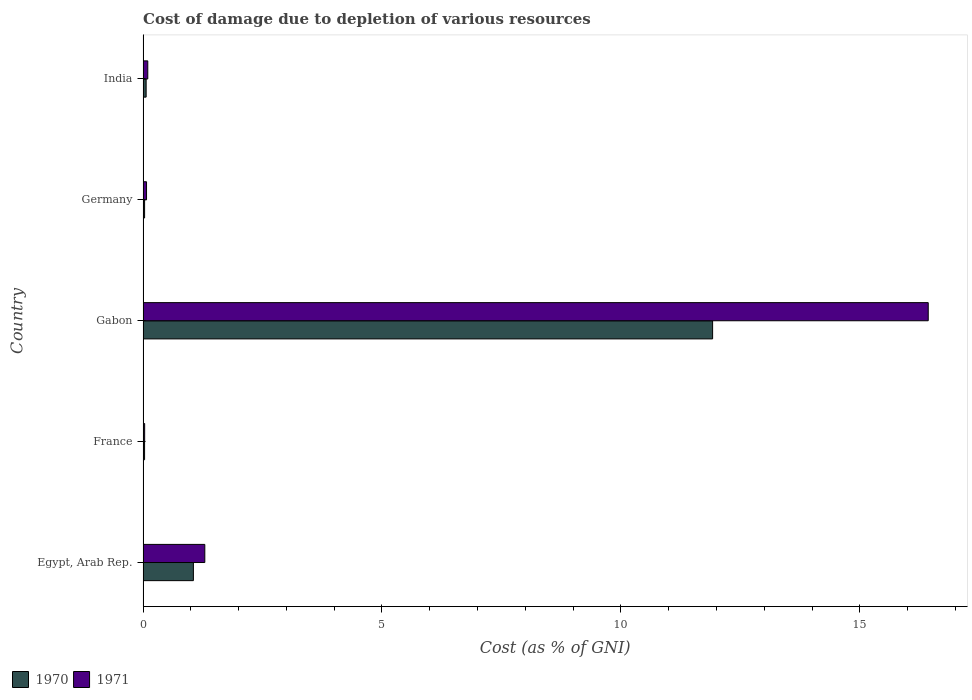How many groups of bars are there?
Your response must be concise. 5. Are the number of bars per tick equal to the number of legend labels?
Give a very brief answer. Yes. How many bars are there on the 3rd tick from the top?
Offer a very short reply. 2. How many bars are there on the 4th tick from the bottom?
Your answer should be very brief. 2. What is the cost of damage caused due to the depletion of various resources in 1970 in India?
Provide a succinct answer. 0.06. Across all countries, what is the maximum cost of damage caused due to the depletion of various resources in 1970?
Provide a succinct answer. 11.92. Across all countries, what is the minimum cost of damage caused due to the depletion of various resources in 1971?
Make the answer very short. 0.03. In which country was the cost of damage caused due to the depletion of various resources in 1971 maximum?
Provide a short and direct response. Gabon. What is the total cost of damage caused due to the depletion of various resources in 1971 in the graph?
Your answer should be compact. 17.93. What is the difference between the cost of damage caused due to the depletion of various resources in 1970 in Gabon and that in India?
Your answer should be compact. 11.85. What is the difference between the cost of damage caused due to the depletion of various resources in 1970 in Egypt, Arab Rep. and the cost of damage caused due to the depletion of various resources in 1971 in France?
Your answer should be very brief. 1.02. What is the average cost of damage caused due to the depletion of various resources in 1970 per country?
Offer a terse response. 2.62. What is the difference between the cost of damage caused due to the depletion of various resources in 1971 and cost of damage caused due to the depletion of various resources in 1970 in Germany?
Your answer should be very brief. 0.04. In how many countries, is the cost of damage caused due to the depletion of various resources in 1970 greater than 3 %?
Your response must be concise. 1. What is the ratio of the cost of damage caused due to the depletion of various resources in 1970 in Egypt, Arab Rep. to that in Gabon?
Make the answer very short. 0.09. Is the cost of damage caused due to the depletion of various resources in 1971 in Egypt, Arab Rep. less than that in India?
Give a very brief answer. No. Is the difference between the cost of damage caused due to the depletion of various resources in 1971 in Egypt, Arab Rep. and Gabon greater than the difference between the cost of damage caused due to the depletion of various resources in 1970 in Egypt, Arab Rep. and Gabon?
Your answer should be compact. No. What is the difference between the highest and the second highest cost of damage caused due to the depletion of various resources in 1970?
Ensure brevity in your answer.  10.87. What is the difference between the highest and the lowest cost of damage caused due to the depletion of various resources in 1970?
Provide a succinct answer. 11.89. In how many countries, is the cost of damage caused due to the depletion of various resources in 1971 greater than the average cost of damage caused due to the depletion of various resources in 1971 taken over all countries?
Give a very brief answer. 1. What does the 1st bar from the top in Germany represents?
Give a very brief answer. 1971. How many bars are there?
Keep it short and to the point. 10. Are all the bars in the graph horizontal?
Offer a very short reply. Yes. How many countries are there in the graph?
Give a very brief answer. 5. What is the difference between two consecutive major ticks on the X-axis?
Your response must be concise. 5. Does the graph contain grids?
Offer a terse response. No. Where does the legend appear in the graph?
Make the answer very short. Bottom left. How many legend labels are there?
Your answer should be compact. 2. How are the legend labels stacked?
Your answer should be very brief. Horizontal. What is the title of the graph?
Provide a short and direct response. Cost of damage due to depletion of various resources. What is the label or title of the X-axis?
Provide a short and direct response. Cost (as % of GNI). What is the Cost (as % of GNI) of 1970 in Egypt, Arab Rep.?
Your response must be concise. 1.05. What is the Cost (as % of GNI) in 1971 in Egypt, Arab Rep.?
Your response must be concise. 1.29. What is the Cost (as % of GNI) of 1970 in France?
Ensure brevity in your answer.  0.03. What is the Cost (as % of GNI) in 1971 in France?
Make the answer very short. 0.03. What is the Cost (as % of GNI) of 1970 in Gabon?
Provide a short and direct response. 11.92. What is the Cost (as % of GNI) in 1971 in Gabon?
Your answer should be very brief. 16.43. What is the Cost (as % of GNI) of 1970 in Germany?
Offer a very short reply. 0.03. What is the Cost (as % of GNI) of 1971 in Germany?
Provide a succinct answer. 0.07. What is the Cost (as % of GNI) of 1970 in India?
Keep it short and to the point. 0.06. What is the Cost (as % of GNI) in 1971 in India?
Keep it short and to the point. 0.1. Across all countries, what is the maximum Cost (as % of GNI) of 1970?
Offer a terse response. 11.92. Across all countries, what is the maximum Cost (as % of GNI) in 1971?
Make the answer very short. 16.43. Across all countries, what is the minimum Cost (as % of GNI) of 1970?
Offer a terse response. 0.03. Across all countries, what is the minimum Cost (as % of GNI) in 1971?
Your answer should be compact. 0.03. What is the total Cost (as % of GNI) of 1970 in the graph?
Make the answer very short. 13.1. What is the total Cost (as % of GNI) of 1971 in the graph?
Offer a very short reply. 17.93. What is the difference between the Cost (as % of GNI) of 1970 in Egypt, Arab Rep. and that in France?
Your answer should be compact. 1.02. What is the difference between the Cost (as % of GNI) of 1971 in Egypt, Arab Rep. and that in France?
Provide a short and direct response. 1.26. What is the difference between the Cost (as % of GNI) of 1970 in Egypt, Arab Rep. and that in Gabon?
Ensure brevity in your answer.  -10.87. What is the difference between the Cost (as % of GNI) in 1971 in Egypt, Arab Rep. and that in Gabon?
Your answer should be compact. -15.14. What is the difference between the Cost (as % of GNI) in 1970 in Egypt, Arab Rep. and that in Germany?
Offer a very short reply. 1.02. What is the difference between the Cost (as % of GNI) in 1971 in Egypt, Arab Rep. and that in Germany?
Offer a terse response. 1.22. What is the difference between the Cost (as % of GNI) in 1970 in Egypt, Arab Rep. and that in India?
Your response must be concise. 0.99. What is the difference between the Cost (as % of GNI) of 1971 in Egypt, Arab Rep. and that in India?
Provide a short and direct response. 1.19. What is the difference between the Cost (as % of GNI) in 1970 in France and that in Gabon?
Offer a very short reply. -11.89. What is the difference between the Cost (as % of GNI) of 1971 in France and that in Gabon?
Provide a short and direct response. -16.4. What is the difference between the Cost (as % of GNI) of 1970 in France and that in Germany?
Your response must be concise. -0. What is the difference between the Cost (as % of GNI) in 1971 in France and that in Germany?
Provide a short and direct response. -0.04. What is the difference between the Cost (as % of GNI) in 1970 in France and that in India?
Provide a short and direct response. -0.03. What is the difference between the Cost (as % of GNI) of 1971 in France and that in India?
Provide a short and direct response. -0.07. What is the difference between the Cost (as % of GNI) of 1970 in Gabon and that in Germany?
Give a very brief answer. 11.89. What is the difference between the Cost (as % of GNI) in 1971 in Gabon and that in Germany?
Give a very brief answer. 16.36. What is the difference between the Cost (as % of GNI) of 1970 in Gabon and that in India?
Provide a short and direct response. 11.86. What is the difference between the Cost (as % of GNI) in 1971 in Gabon and that in India?
Your response must be concise. 16.33. What is the difference between the Cost (as % of GNI) in 1970 in Germany and that in India?
Keep it short and to the point. -0.03. What is the difference between the Cost (as % of GNI) in 1971 in Germany and that in India?
Give a very brief answer. -0.03. What is the difference between the Cost (as % of GNI) of 1970 in Egypt, Arab Rep. and the Cost (as % of GNI) of 1971 in France?
Your answer should be very brief. 1.02. What is the difference between the Cost (as % of GNI) of 1970 in Egypt, Arab Rep. and the Cost (as % of GNI) of 1971 in Gabon?
Offer a terse response. -15.38. What is the difference between the Cost (as % of GNI) of 1970 in Egypt, Arab Rep. and the Cost (as % of GNI) of 1971 in Germany?
Provide a short and direct response. 0.98. What is the difference between the Cost (as % of GNI) in 1970 in Egypt, Arab Rep. and the Cost (as % of GNI) in 1971 in India?
Give a very brief answer. 0.95. What is the difference between the Cost (as % of GNI) of 1970 in France and the Cost (as % of GNI) of 1971 in Gabon?
Ensure brevity in your answer.  -16.4. What is the difference between the Cost (as % of GNI) in 1970 in France and the Cost (as % of GNI) in 1971 in Germany?
Ensure brevity in your answer.  -0.04. What is the difference between the Cost (as % of GNI) of 1970 in France and the Cost (as % of GNI) of 1971 in India?
Your answer should be compact. -0.07. What is the difference between the Cost (as % of GNI) in 1970 in Gabon and the Cost (as % of GNI) in 1971 in Germany?
Your answer should be compact. 11.85. What is the difference between the Cost (as % of GNI) in 1970 in Gabon and the Cost (as % of GNI) in 1971 in India?
Make the answer very short. 11.82. What is the difference between the Cost (as % of GNI) of 1970 in Germany and the Cost (as % of GNI) of 1971 in India?
Your answer should be compact. -0.07. What is the average Cost (as % of GNI) in 1970 per country?
Give a very brief answer. 2.62. What is the average Cost (as % of GNI) of 1971 per country?
Your response must be concise. 3.59. What is the difference between the Cost (as % of GNI) of 1970 and Cost (as % of GNI) of 1971 in Egypt, Arab Rep.?
Give a very brief answer. -0.24. What is the difference between the Cost (as % of GNI) of 1970 and Cost (as % of GNI) of 1971 in France?
Keep it short and to the point. -0. What is the difference between the Cost (as % of GNI) of 1970 and Cost (as % of GNI) of 1971 in Gabon?
Offer a terse response. -4.51. What is the difference between the Cost (as % of GNI) in 1970 and Cost (as % of GNI) in 1971 in Germany?
Keep it short and to the point. -0.04. What is the difference between the Cost (as % of GNI) in 1970 and Cost (as % of GNI) in 1971 in India?
Offer a terse response. -0.03. What is the ratio of the Cost (as % of GNI) of 1970 in Egypt, Arab Rep. to that in France?
Give a very brief answer. 33.37. What is the ratio of the Cost (as % of GNI) of 1971 in Egypt, Arab Rep. to that in France?
Give a very brief answer. 38.77. What is the ratio of the Cost (as % of GNI) in 1970 in Egypt, Arab Rep. to that in Gabon?
Offer a very short reply. 0.09. What is the ratio of the Cost (as % of GNI) in 1971 in Egypt, Arab Rep. to that in Gabon?
Offer a very short reply. 0.08. What is the ratio of the Cost (as % of GNI) of 1970 in Egypt, Arab Rep. to that in Germany?
Provide a short and direct response. 32.93. What is the ratio of the Cost (as % of GNI) of 1971 in Egypt, Arab Rep. to that in Germany?
Keep it short and to the point. 17.84. What is the ratio of the Cost (as % of GNI) in 1970 in Egypt, Arab Rep. to that in India?
Your answer should be very brief. 16.34. What is the ratio of the Cost (as % of GNI) in 1971 in Egypt, Arab Rep. to that in India?
Your response must be concise. 13.1. What is the ratio of the Cost (as % of GNI) in 1970 in France to that in Gabon?
Your answer should be very brief. 0. What is the ratio of the Cost (as % of GNI) of 1971 in France to that in Gabon?
Give a very brief answer. 0. What is the ratio of the Cost (as % of GNI) in 1970 in France to that in Germany?
Ensure brevity in your answer.  0.99. What is the ratio of the Cost (as % of GNI) in 1971 in France to that in Germany?
Ensure brevity in your answer.  0.46. What is the ratio of the Cost (as % of GNI) of 1970 in France to that in India?
Offer a terse response. 0.49. What is the ratio of the Cost (as % of GNI) of 1971 in France to that in India?
Your answer should be very brief. 0.34. What is the ratio of the Cost (as % of GNI) of 1970 in Gabon to that in Germany?
Make the answer very short. 372.66. What is the ratio of the Cost (as % of GNI) in 1971 in Gabon to that in Germany?
Provide a succinct answer. 226.83. What is the ratio of the Cost (as % of GNI) of 1970 in Gabon to that in India?
Your response must be concise. 184.89. What is the ratio of the Cost (as % of GNI) in 1971 in Gabon to that in India?
Offer a very short reply. 166.63. What is the ratio of the Cost (as % of GNI) in 1970 in Germany to that in India?
Provide a succinct answer. 0.5. What is the ratio of the Cost (as % of GNI) in 1971 in Germany to that in India?
Your answer should be compact. 0.73. What is the difference between the highest and the second highest Cost (as % of GNI) in 1970?
Make the answer very short. 10.87. What is the difference between the highest and the second highest Cost (as % of GNI) of 1971?
Give a very brief answer. 15.14. What is the difference between the highest and the lowest Cost (as % of GNI) of 1970?
Make the answer very short. 11.89. What is the difference between the highest and the lowest Cost (as % of GNI) of 1971?
Provide a succinct answer. 16.4. 